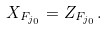Convert formula to latex. <formula><loc_0><loc_0><loc_500><loc_500>X _ { F _ { j _ { 0 } } } = Z _ { F _ { j _ { 0 } } } .</formula> 